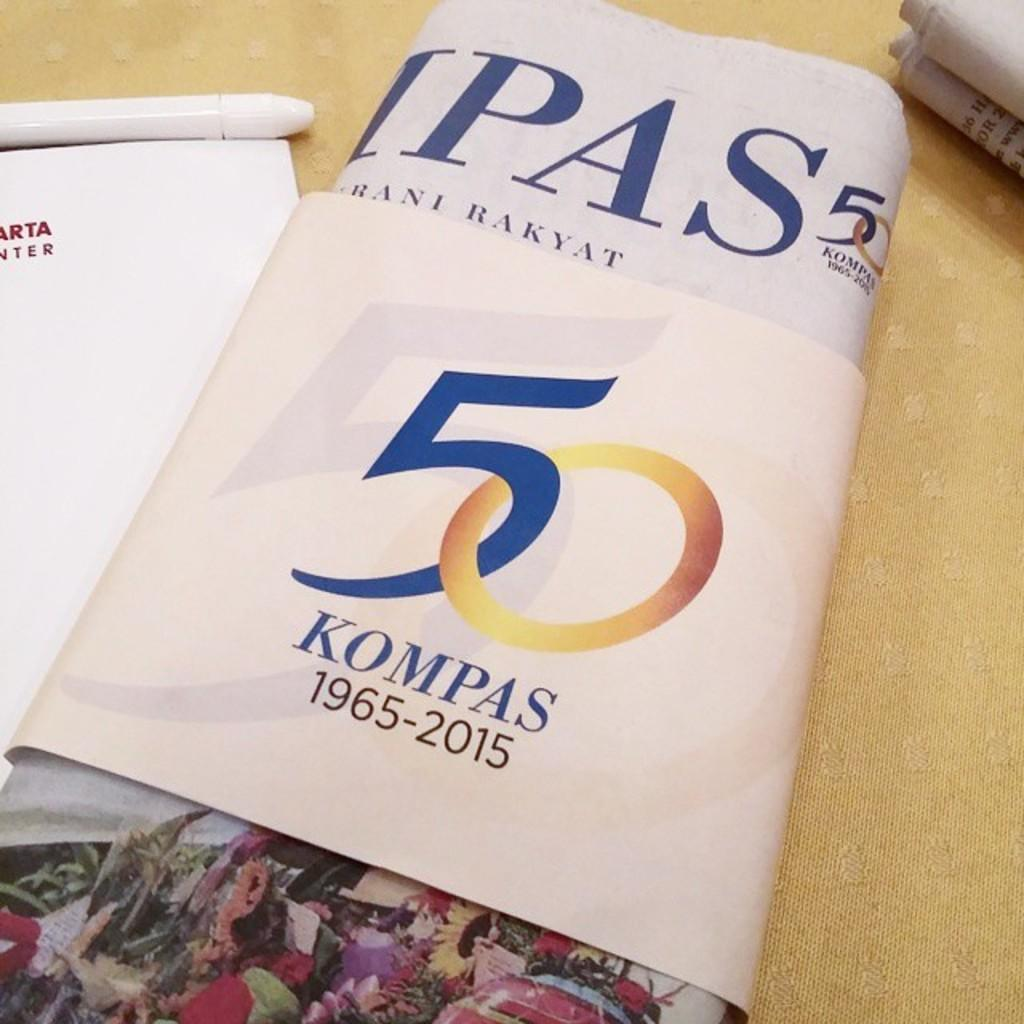What type of reading material is present in the image? There are newspapers in the image. What writing instrument can be seen in the image? There is a pen in the image. What else is present on the tablecloth besides newspapers and a pen? There is a book in the image. How many engines are visible in the image? There are no engines present in the image. What type of clocks can be seen on the tablecloth? There are no clocks present in the image. 